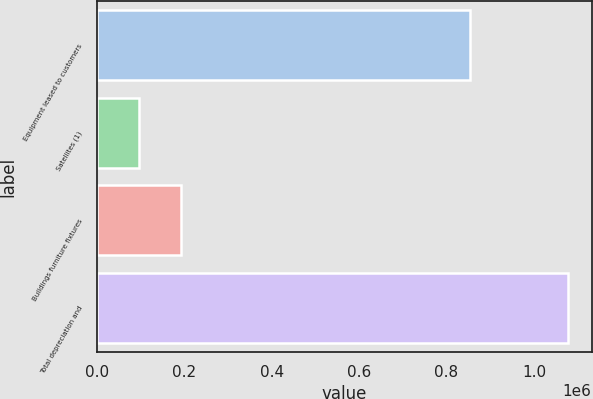<chart> <loc_0><loc_0><loc_500><loc_500><bar_chart><fcel>Equipment leased to customers<fcel>Satellites (1)<fcel>Buildings furniture fixtures<fcel>Total depreciation and<nl><fcel>854759<fcel>95766<fcel>193983<fcel>1.07794e+06<nl></chart> 